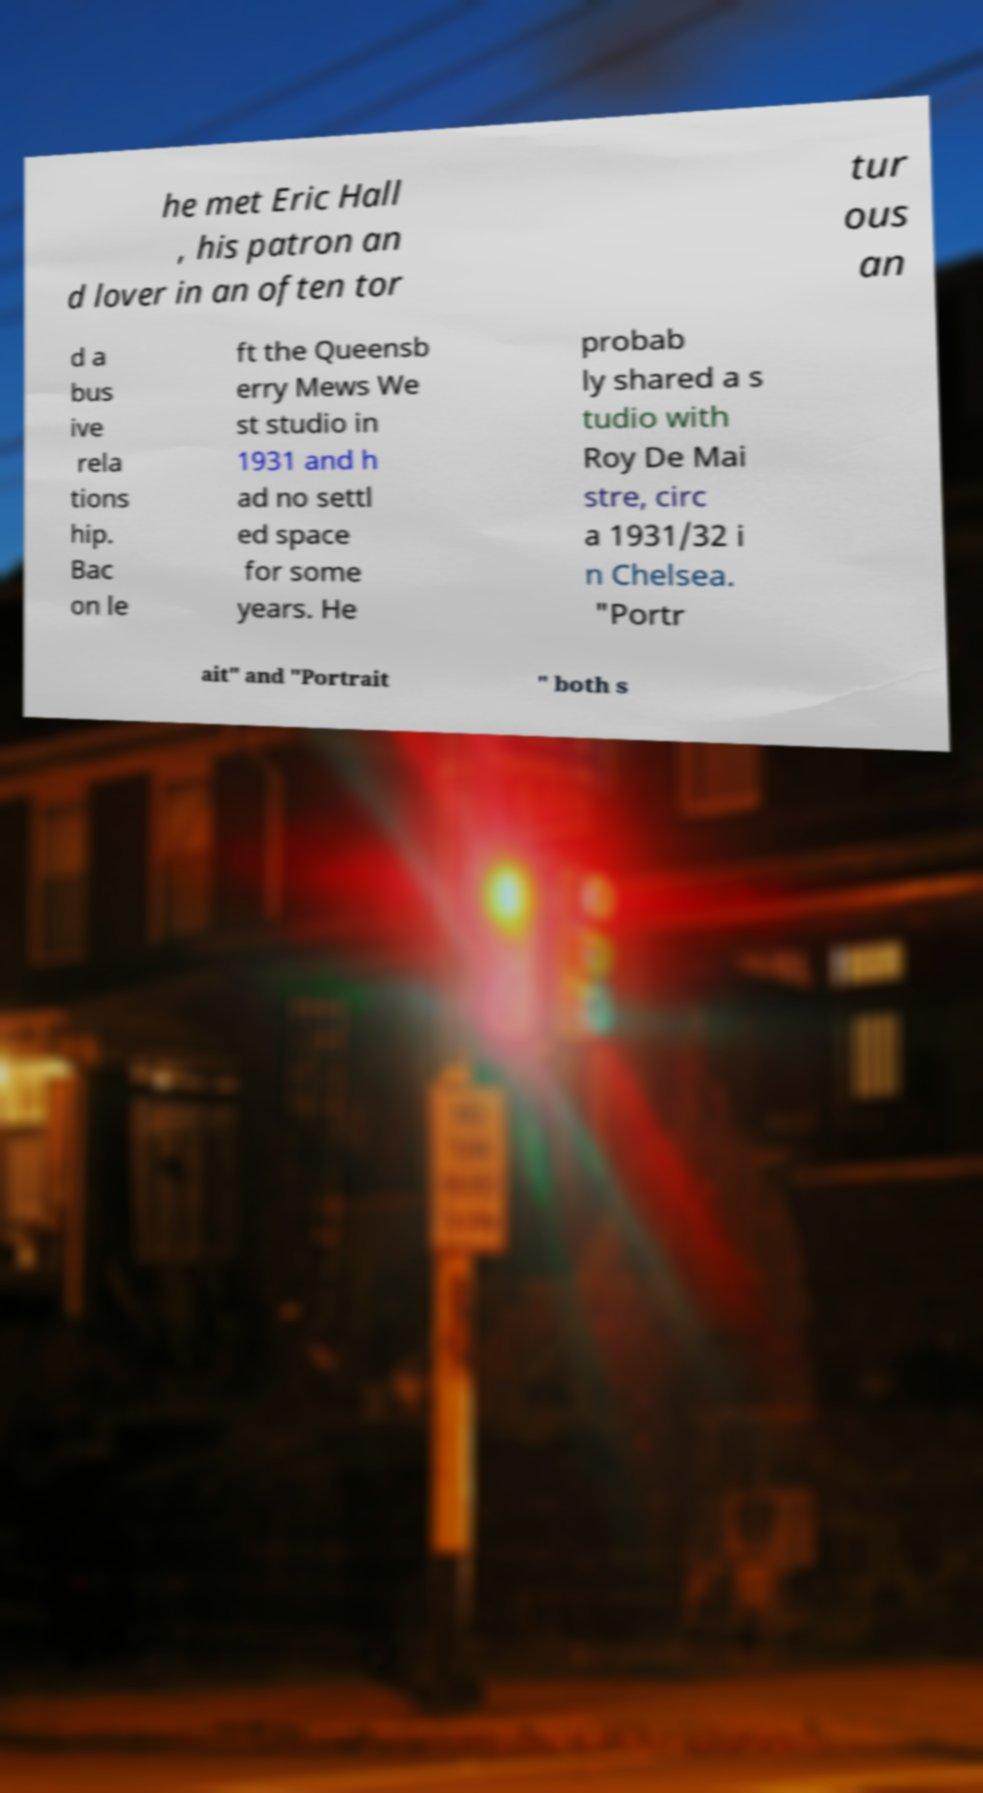For documentation purposes, I need the text within this image transcribed. Could you provide that? he met Eric Hall , his patron an d lover in an often tor tur ous an d a bus ive rela tions hip. Bac on le ft the Queensb erry Mews We st studio in 1931 and h ad no settl ed space for some years. He probab ly shared a s tudio with Roy De Mai stre, circ a 1931/32 i n Chelsea. "Portr ait" and "Portrait " both s 